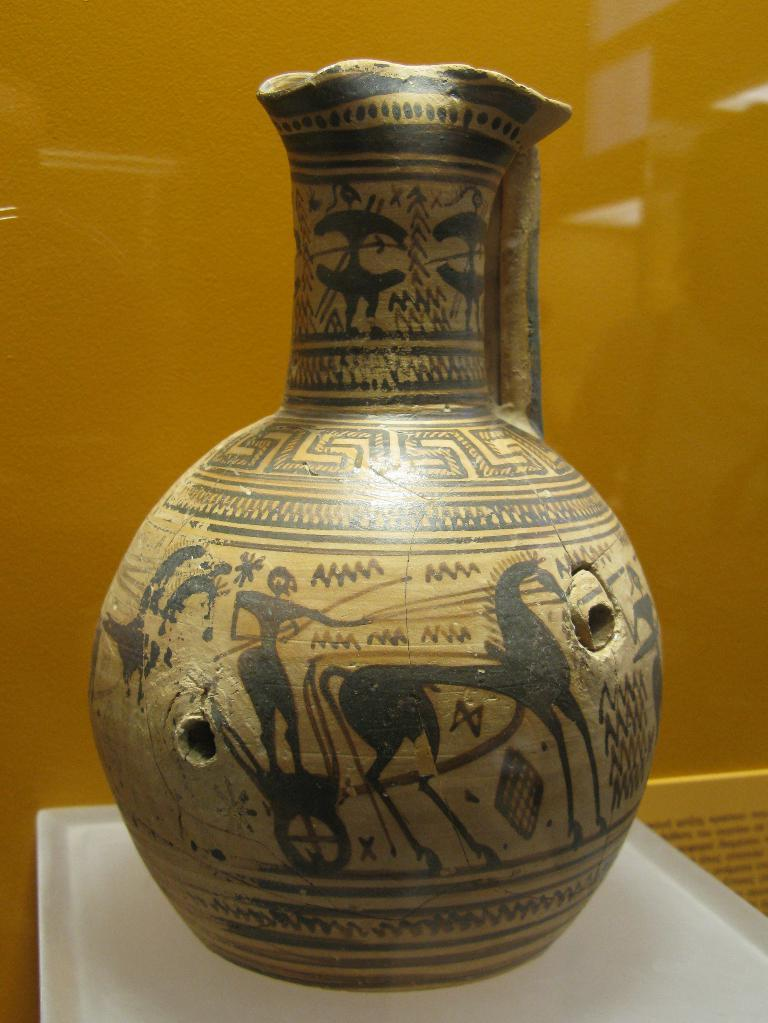What is placed on the tray in the image? There is a vase with designs on a tray in the image. What can be seen behind the vase? There is a wall visible behind the vase. What type of sidewalk is visible in the image? There is no sidewalk present in the image. What does the mom say about the vase in the image? There is no mom present in the image, so it is not possible to determine what she might say about the vase. 